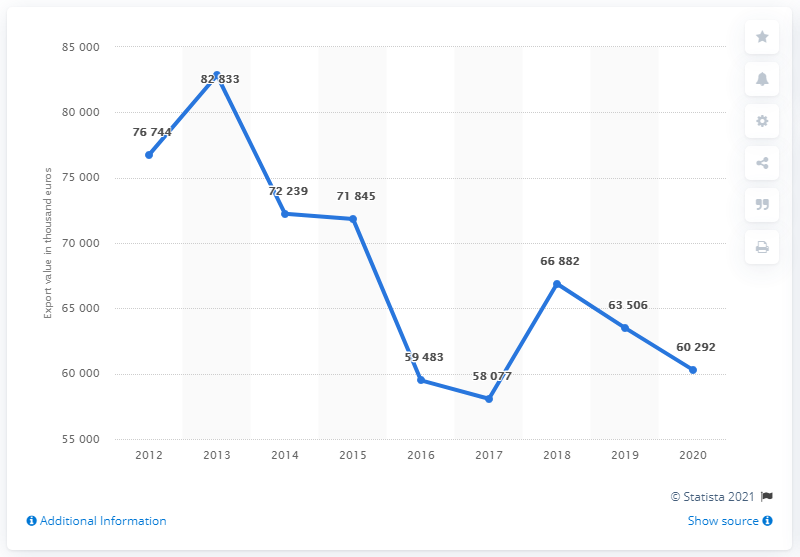Highlight a few significant elements in this photo. The maximum value is 82833. In 2017, the value of tomatoes was the lowest out of all the years studied. 